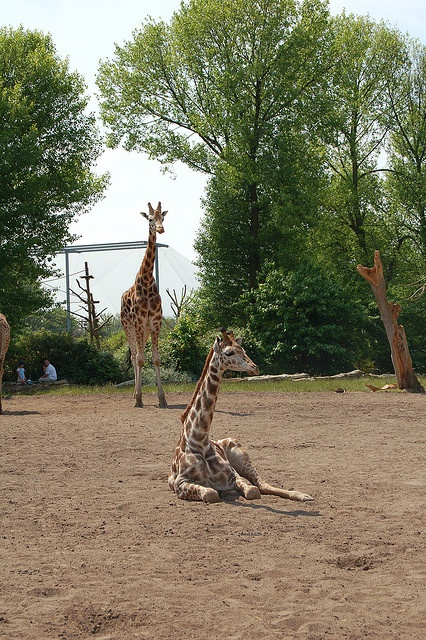Describe the objects in this image and their specific colors. I can see giraffe in white, gray, maroon, and black tones, giraffe in white, gray, and maroon tones, giraffe in white, gray, maroon, and black tones, people in white, gray, and black tones, and people in white, black, gray, and maroon tones in this image. 